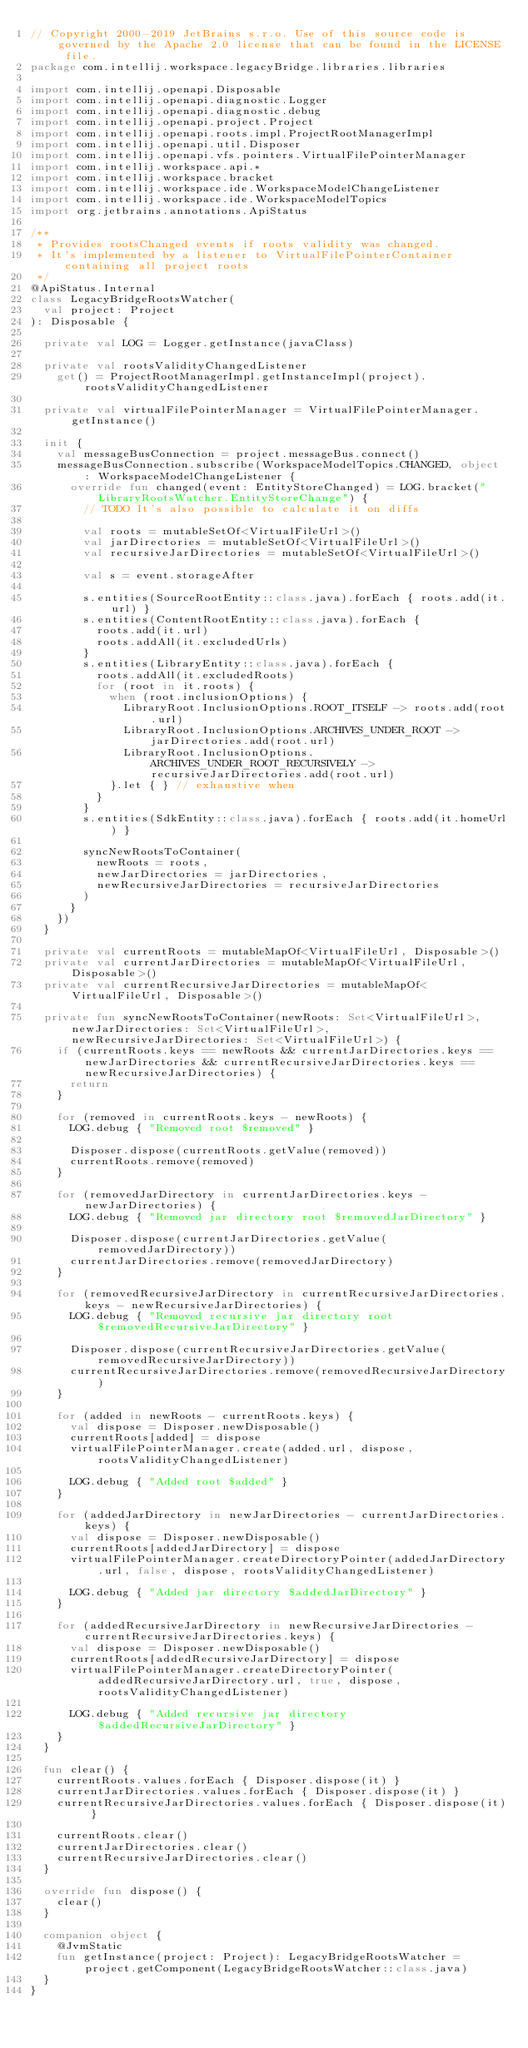Convert code to text. <code><loc_0><loc_0><loc_500><loc_500><_Kotlin_>// Copyright 2000-2019 JetBrains s.r.o. Use of this source code is governed by the Apache 2.0 license that can be found in the LICENSE file.
package com.intellij.workspace.legacyBridge.libraries.libraries

import com.intellij.openapi.Disposable
import com.intellij.openapi.diagnostic.Logger
import com.intellij.openapi.diagnostic.debug
import com.intellij.openapi.project.Project
import com.intellij.openapi.roots.impl.ProjectRootManagerImpl
import com.intellij.openapi.util.Disposer
import com.intellij.openapi.vfs.pointers.VirtualFilePointerManager
import com.intellij.workspace.api.*
import com.intellij.workspace.bracket
import com.intellij.workspace.ide.WorkspaceModelChangeListener
import com.intellij.workspace.ide.WorkspaceModelTopics
import org.jetbrains.annotations.ApiStatus

/**
 * Provides rootsChanged events if roots validity was changed.
 * It's implemented by a listener to VirtualFilePointerContainer containing all project roots
 */
@ApiStatus.Internal
class LegacyBridgeRootsWatcher(
  val project: Project
): Disposable {

  private val LOG = Logger.getInstance(javaClass)

  private val rootsValidityChangedListener
    get() = ProjectRootManagerImpl.getInstanceImpl(project).rootsValidityChangedListener

  private val virtualFilePointerManager = VirtualFilePointerManager.getInstance()

  init {
    val messageBusConnection = project.messageBus.connect()
    messageBusConnection.subscribe(WorkspaceModelTopics.CHANGED, object : WorkspaceModelChangeListener {
      override fun changed(event: EntityStoreChanged) = LOG.bracket("LibraryRootsWatcher.EntityStoreChange") {
        // TODO It's also possible to calculate it on diffs

        val roots = mutableSetOf<VirtualFileUrl>()
        val jarDirectories = mutableSetOf<VirtualFileUrl>()
        val recursiveJarDirectories = mutableSetOf<VirtualFileUrl>()

        val s = event.storageAfter

        s.entities(SourceRootEntity::class.java).forEach { roots.add(it.url) }
        s.entities(ContentRootEntity::class.java).forEach {
          roots.add(it.url)
          roots.addAll(it.excludedUrls)
        }
        s.entities(LibraryEntity::class.java).forEach {
          roots.addAll(it.excludedRoots)
          for (root in it.roots) {
            when (root.inclusionOptions) {
              LibraryRoot.InclusionOptions.ROOT_ITSELF -> roots.add(root.url)
              LibraryRoot.InclusionOptions.ARCHIVES_UNDER_ROOT -> jarDirectories.add(root.url)
              LibraryRoot.InclusionOptions.ARCHIVES_UNDER_ROOT_RECURSIVELY -> recursiveJarDirectories.add(root.url)
            }.let { } // exhaustive when
          }
        }
        s.entities(SdkEntity::class.java).forEach { roots.add(it.homeUrl) }

        syncNewRootsToContainer(
          newRoots = roots,
          newJarDirectories = jarDirectories,
          newRecursiveJarDirectories = recursiveJarDirectories
        )
      }
    })
  }

  private val currentRoots = mutableMapOf<VirtualFileUrl, Disposable>()
  private val currentJarDirectories = mutableMapOf<VirtualFileUrl, Disposable>()
  private val currentRecursiveJarDirectories = mutableMapOf<VirtualFileUrl, Disposable>()

  private fun syncNewRootsToContainer(newRoots: Set<VirtualFileUrl>, newJarDirectories: Set<VirtualFileUrl>, newRecursiveJarDirectories: Set<VirtualFileUrl>) {
    if (currentRoots.keys == newRoots && currentJarDirectories.keys == newJarDirectories && currentRecursiveJarDirectories.keys == newRecursiveJarDirectories) {
      return
    }

    for (removed in currentRoots.keys - newRoots) {
      LOG.debug { "Removed root $removed" }

      Disposer.dispose(currentRoots.getValue(removed))
      currentRoots.remove(removed)
    }

    for (removedJarDirectory in currentJarDirectories.keys - newJarDirectories) {
      LOG.debug { "Removed jar directory root $removedJarDirectory" }

      Disposer.dispose(currentJarDirectories.getValue(removedJarDirectory))
      currentJarDirectories.remove(removedJarDirectory)
    }

    for (removedRecursiveJarDirectory in currentRecursiveJarDirectories.keys - newRecursiveJarDirectories) {
      LOG.debug { "Removed recursive jar directory root $removedRecursiveJarDirectory" }

      Disposer.dispose(currentRecursiveJarDirectories.getValue(removedRecursiveJarDirectory))
      currentRecursiveJarDirectories.remove(removedRecursiveJarDirectory)
    }

    for (added in newRoots - currentRoots.keys) {
      val dispose = Disposer.newDisposable()
      currentRoots[added] = dispose
      virtualFilePointerManager.create(added.url, dispose, rootsValidityChangedListener)

      LOG.debug { "Added root $added" }
    }

    for (addedJarDirectory in newJarDirectories - currentJarDirectories.keys) {
      val dispose = Disposer.newDisposable()
      currentRoots[addedJarDirectory] = dispose
      virtualFilePointerManager.createDirectoryPointer(addedJarDirectory.url, false, dispose, rootsValidityChangedListener)

      LOG.debug { "Added jar directory $addedJarDirectory" }
    }

    for (addedRecursiveJarDirectory in newRecursiveJarDirectories - currentRecursiveJarDirectories.keys) {
      val dispose = Disposer.newDisposable()
      currentRoots[addedRecursiveJarDirectory] = dispose
      virtualFilePointerManager.createDirectoryPointer(addedRecursiveJarDirectory.url, true, dispose, rootsValidityChangedListener)

      LOG.debug { "Added recursive jar directory $addedRecursiveJarDirectory" }
    }
  }

  fun clear() {
    currentRoots.values.forEach { Disposer.dispose(it) }
    currentJarDirectories.values.forEach { Disposer.dispose(it) }
    currentRecursiveJarDirectories.values.forEach { Disposer.dispose(it) }

    currentRoots.clear()
    currentJarDirectories.clear()
    currentRecursiveJarDirectories.clear()
  }

  override fun dispose() {
    clear()
  }

  companion object {
    @JvmStatic
    fun getInstance(project: Project): LegacyBridgeRootsWatcher = project.getComponent(LegacyBridgeRootsWatcher::class.java)
  }
}
</code> 